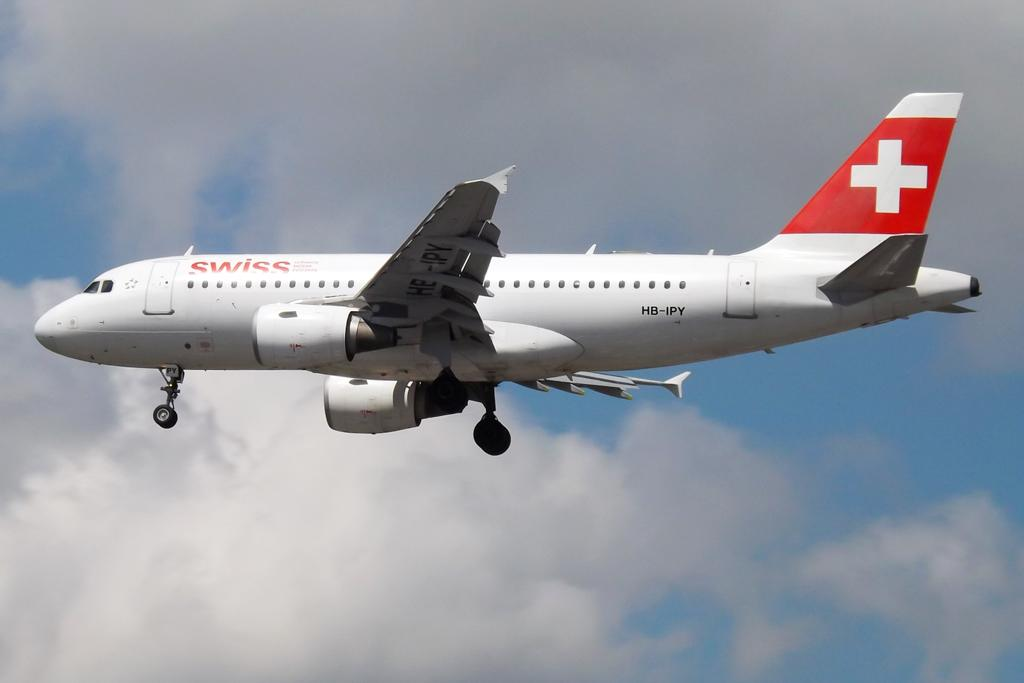What is the main subject of the image? The main subject of the image is an airplane. What is the airplane doing in the image? The airplane is flying in the image. What can be seen in the background of the image? The sky is visible in the background of the image. What else is present in the sky? Clouds are present in the sky. How many oranges are being rubbed by the zebra in the image? There is no zebra or oranges present in the image. 